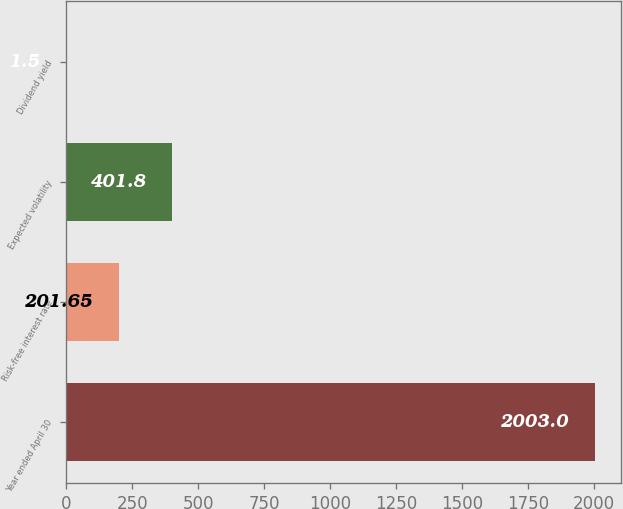Convert chart. <chart><loc_0><loc_0><loc_500><loc_500><bar_chart><fcel>Year ended April 30<fcel>Risk-free interest rate<fcel>Expected volatility<fcel>Dividend yield<nl><fcel>2003<fcel>201.65<fcel>401.8<fcel>1.5<nl></chart> 